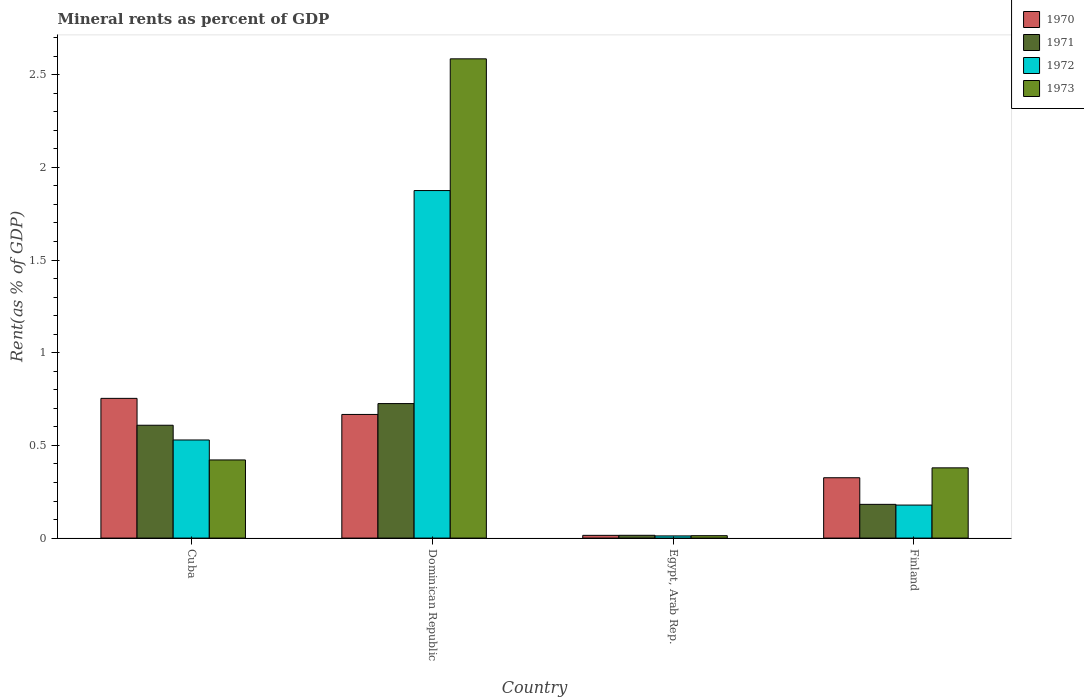How many different coloured bars are there?
Offer a terse response. 4. How many groups of bars are there?
Offer a terse response. 4. Are the number of bars per tick equal to the number of legend labels?
Your answer should be compact. Yes. How many bars are there on the 2nd tick from the left?
Provide a succinct answer. 4. What is the label of the 3rd group of bars from the left?
Provide a short and direct response. Egypt, Arab Rep. What is the mineral rent in 1970 in Finland?
Offer a terse response. 0.33. Across all countries, what is the maximum mineral rent in 1970?
Offer a very short reply. 0.75. Across all countries, what is the minimum mineral rent in 1971?
Your answer should be very brief. 0.02. In which country was the mineral rent in 1970 maximum?
Keep it short and to the point. Cuba. In which country was the mineral rent in 1970 minimum?
Offer a terse response. Egypt, Arab Rep. What is the total mineral rent in 1970 in the graph?
Provide a short and direct response. 1.76. What is the difference between the mineral rent in 1972 in Cuba and that in Finland?
Your response must be concise. 0.35. What is the difference between the mineral rent in 1971 in Dominican Republic and the mineral rent in 1973 in Finland?
Give a very brief answer. 0.35. What is the average mineral rent in 1972 per country?
Offer a very short reply. 0.65. What is the difference between the mineral rent of/in 1970 and mineral rent of/in 1971 in Cuba?
Give a very brief answer. 0.14. What is the ratio of the mineral rent in 1972 in Dominican Republic to that in Finland?
Keep it short and to the point. 10.53. Is the mineral rent in 1971 in Egypt, Arab Rep. less than that in Finland?
Your answer should be very brief. Yes. Is the difference between the mineral rent in 1970 in Dominican Republic and Egypt, Arab Rep. greater than the difference between the mineral rent in 1971 in Dominican Republic and Egypt, Arab Rep.?
Your answer should be compact. No. What is the difference between the highest and the second highest mineral rent in 1971?
Provide a short and direct response. 0.12. What is the difference between the highest and the lowest mineral rent in 1971?
Make the answer very short. 0.71. Is the sum of the mineral rent in 1972 in Cuba and Finland greater than the maximum mineral rent in 1971 across all countries?
Provide a succinct answer. No. What does the 1st bar from the left in Egypt, Arab Rep. represents?
Ensure brevity in your answer.  1970. Is it the case that in every country, the sum of the mineral rent in 1971 and mineral rent in 1972 is greater than the mineral rent in 1973?
Make the answer very short. No. How many countries are there in the graph?
Your response must be concise. 4. Are the values on the major ticks of Y-axis written in scientific E-notation?
Provide a succinct answer. No. Does the graph contain grids?
Offer a very short reply. No. Where does the legend appear in the graph?
Provide a succinct answer. Top right. How are the legend labels stacked?
Ensure brevity in your answer.  Vertical. What is the title of the graph?
Offer a very short reply. Mineral rents as percent of GDP. Does "2004" appear as one of the legend labels in the graph?
Your answer should be very brief. No. What is the label or title of the X-axis?
Offer a terse response. Country. What is the label or title of the Y-axis?
Provide a short and direct response. Rent(as % of GDP). What is the Rent(as % of GDP) of 1970 in Cuba?
Give a very brief answer. 0.75. What is the Rent(as % of GDP) in 1971 in Cuba?
Your response must be concise. 0.61. What is the Rent(as % of GDP) in 1972 in Cuba?
Ensure brevity in your answer.  0.53. What is the Rent(as % of GDP) of 1973 in Cuba?
Ensure brevity in your answer.  0.42. What is the Rent(as % of GDP) of 1970 in Dominican Republic?
Make the answer very short. 0.67. What is the Rent(as % of GDP) of 1971 in Dominican Republic?
Offer a very short reply. 0.73. What is the Rent(as % of GDP) in 1972 in Dominican Republic?
Your response must be concise. 1.87. What is the Rent(as % of GDP) of 1973 in Dominican Republic?
Your answer should be compact. 2.59. What is the Rent(as % of GDP) in 1970 in Egypt, Arab Rep.?
Offer a terse response. 0.01. What is the Rent(as % of GDP) of 1971 in Egypt, Arab Rep.?
Give a very brief answer. 0.02. What is the Rent(as % of GDP) of 1972 in Egypt, Arab Rep.?
Provide a succinct answer. 0.01. What is the Rent(as % of GDP) of 1973 in Egypt, Arab Rep.?
Your answer should be compact. 0.01. What is the Rent(as % of GDP) in 1970 in Finland?
Provide a short and direct response. 0.33. What is the Rent(as % of GDP) in 1971 in Finland?
Your answer should be very brief. 0.18. What is the Rent(as % of GDP) of 1972 in Finland?
Offer a terse response. 0.18. What is the Rent(as % of GDP) in 1973 in Finland?
Give a very brief answer. 0.38. Across all countries, what is the maximum Rent(as % of GDP) of 1970?
Keep it short and to the point. 0.75. Across all countries, what is the maximum Rent(as % of GDP) of 1971?
Keep it short and to the point. 0.73. Across all countries, what is the maximum Rent(as % of GDP) in 1972?
Provide a succinct answer. 1.87. Across all countries, what is the maximum Rent(as % of GDP) in 1973?
Offer a very short reply. 2.59. Across all countries, what is the minimum Rent(as % of GDP) in 1970?
Your answer should be compact. 0.01. Across all countries, what is the minimum Rent(as % of GDP) in 1971?
Ensure brevity in your answer.  0.02. Across all countries, what is the minimum Rent(as % of GDP) in 1972?
Make the answer very short. 0.01. Across all countries, what is the minimum Rent(as % of GDP) in 1973?
Offer a terse response. 0.01. What is the total Rent(as % of GDP) of 1970 in the graph?
Your response must be concise. 1.76. What is the total Rent(as % of GDP) in 1971 in the graph?
Give a very brief answer. 1.53. What is the total Rent(as % of GDP) in 1972 in the graph?
Ensure brevity in your answer.  2.59. What is the total Rent(as % of GDP) in 1973 in the graph?
Provide a short and direct response. 3.4. What is the difference between the Rent(as % of GDP) in 1970 in Cuba and that in Dominican Republic?
Offer a terse response. 0.09. What is the difference between the Rent(as % of GDP) of 1971 in Cuba and that in Dominican Republic?
Your response must be concise. -0.12. What is the difference between the Rent(as % of GDP) in 1972 in Cuba and that in Dominican Republic?
Make the answer very short. -1.35. What is the difference between the Rent(as % of GDP) in 1973 in Cuba and that in Dominican Republic?
Provide a succinct answer. -2.16. What is the difference between the Rent(as % of GDP) of 1970 in Cuba and that in Egypt, Arab Rep.?
Ensure brevity in your answer.  0.74. What is the difference between the Rent(as % of GDP) in 1971 in Cuba and that in Egypt, Arab Rep.?
Offer a terse response. 0.59. What is the difference between the Rent(as % of GDP) of 1972 in Cuba and that in Egypt, Arab Rep.?
Keep it short and to the point. 0.52. What is the difference between the Rent(as % of GDP) of 1973 in Cuba and that in Egypt, Arab Rep.?
Offer a very short reply. 0.41. What is the difference between the Rent(as % of GDP) of 1970 in Cuba and that in Finland?
Make the answer very short. 0.43. What is the difference between the Rent(as % of GDP) in 1971 in Cuba and that in Finland?
Your answer should be compact. 0.43. What is the difference between the Rent(as % of GDP) of 1972 in Cuba and that in Finland?
Provide a succinct answer. 0.35. What is the difference between the Rent(as % of GDP) of 1973 in Cuba and that in Finland?
Ensure brevity in your answer.  0.04. What is the difference between the Rent(as % of GDP) of 1970 in Dominican Republic and that in Egypt, Arab Rep.?
Offer a very short reply. 0.65. What is the difference between the Rent(as % of GDP) in 1971 in Dominican Republic and that in Egypt, Arab Rep.?
Your answer should be compact. 0.71. What is the difference between the Rent(as % of GDP) of 1972 in Dominican Republic and that in Egypt, Arab Rep.?
Give a very brief answer. 1.86. What is the difference between the Rent(as % of GDP) of 1973 in Dominican Republic and that in Egypt, Arab Rep.?
Give a very brief answer. 2.57. What is the difference between the Rent(as % of GDP) in 1970 in Dominican Republic and that in Finland?
Your answer should be compact. 0.34. What is the difference between the Rent(as % of GDP) of 1971 in Dominican Republic and that in Finland?
Keep it short and to the point. 0.54. What is the difference between the Rent(as % of GDP) of 1972 in Dominican Republic and that in Finland?
Provide a succinct answer. 1.7. What is the difference between the Rent(as % of GDP) of 1973 in Dominican Republic and that in Finland?
Give a very brief answer. 2.21. What is the difference between the Rent(as % of GDP) of 1970 in Egypt, Arab Rep. and that in Finland?
Keep it short and to the point. -0.31. What is the difference between the Rent(as % of GDP) of 1971 in Egypt, Arab Rep. and that in Finland?
Offer a terse response. -0.17. What is the difference between the Rent(as % of GDP) in 1972 in Egypt, Arab Rep. and that in Finland?
Offer a very short reply. -0.17. What is the difference between the Rent(as % of GDP) in 1973 in Egypt, Arab Rep. and that in Finland?
Your answer should be compact. -0.37. What is the difference between the Rent(as % of GDP) of 1970 in Cuba and the Rent(as % of GDP) of 1971 in Dominican Republic?
Keep it short and to the point. 0.03. What is the difference between the Rent(as % of GDP) of 1970 in Cuba and the Rent(as % of GDP) of 1972 in Dominican Republic?
Your answer should be compact. -1.12. What is the difference between the Rent(as % of GDP) in 1970 in Cuba and the Rent(as % of GDP) in 1973 in Dominican Republic?
Make the answer very short. -1.83. What is the difference between the Rent(as % of GDP) in 1971 in Cuba and the Rent(as % of GDP) in 1972 in Dominican Republic?
Offer a very short reply. -1.27. What is the difference between the Rent(as % of GDP) in 1971 in Cuba and the Rent(as % of GDP) in 1973 in Dominican Republic?
Offer a terse response. -1.98. What is the difference between the Rent(as % of GDP) of 1972 in Cuba and the Rent(as % of GDP) of 1973 in Dominican Republic?
Your answer should be very brief. -2.06. What is the difference between the Rent(as % of GDP) in 1970 in Cuba and the Rent(as % of GDP) in 1971 in Egypt, Arab Rep.?
Give a very brief answer. 0.74. What is the difference between the Rent(as % of GDP) in 1970 in Cuba and the Rent(as % of GDP) in 1972 in Egypt, Arab Rep.?
Ensure brevity in your answer.  0.74. What is the difference between the Rent(as % of GDP) in 1970 in Cuba and the Rent(as % of GDP) in 1973 in Egypt, Arab Rep.?
Your answer should be compact. 0.74. What is the difference between the Rent(as % of GDP) of 1971 in Cuba and the Rent(as % of GDP) of 1972 in Egypt, Arab Rep.?
Offer a terse response. 0.6. What is the difference between the Rent(as % of GDP) of 1971 in Cuba and the Rent(as % of GDP) of 1973 in Egypt, Arab Rep.?
Offer a terse response. 0.6. What is the difference between the Rent(as % of GDP) of 1972 in Cuba and the Rent(as % of GDP) of 1973 in Egypt, Arab Rep.?
Keep it short and to the point. 0.52. What is the difference between the Rent(as % of GDP) of 1970 in Cuba and the Rent(as % of GDP) of 1971 in Finland?
Provide a short and direct response. 0.57. What is the difference between the Rent(as % of GDP) in 1970 in Cuba and the Rent(as % of GDP) in 1972 in Finland?
Ensure brevity in your answer.  0.58. What is the difference between the Rent(as % of GDP) of 1970 in Cuba and the Rent(as % of GDP) of 1973 in Finland?
Ensure brevity in your answer.  0.37. What is the difference between the Rent(as % of GDP) of 1971 in Cuba and the Rent(as % of GDP) of 1972 in Finland?
Give a very brief answer. 0.43. What is the difference between the Rent(as % of GDP) in 1971 in Cuba and the Rent(as % of GDP) in 1973 in Finland?
Keep it short and to the point. 0.23. What is the difference between the Rent(as % of GDP) of 1972 in Cuba and the Rent(as % of GDP) of 1973 in Finland?
Keep it short and to the point. 0.15. What is the difference between the Rent(as % of GDP) in 1970 in Dominican Republic and the Rent(as % of GDP) in 1971 in Egypt, Arab Rep.?
Your answer should be very brief. 0.65. What is the difference between the Rent(as % of GDP) of 1970 in Dominican Republic and the Rent(as % of GDP) of 1972 in Egypt, Arab Rep.?
Ensure brevity in your answer.  0.66. What is the difference between the Rent(as % of GDP) in 1970 in Dominican Republic and the Rent(as % of GDP) in 1973 in Egypt, Arab Rep.?
Make the answer very short. 0.65. What is the difference between the Rent(as % of GDP) of 1971 in Dominican Republic and the Rent(as % of GDP) of 1972 in Egypt, Arab Rep.?
Make the answer very short. 0.71. What is the difference between the Rent(as % of GDP) in 1971 in Dominican Republic and the Rent(as % of GDP) in 1973 in Egypt, Arab Rep.?
Your response must be concise. 0.71. What is the difference between the Rent(as % of GDP) of 1972 in Dominican Republic and the Rent(as % of GDP) of 1973 in Egypt, Arab Rep.?
Ensure brevity in your answer.  1.86. What is the difference between the Rent(as % of GDP) of 1970 in Dominican Republic and the Rent(as % of GDP) of 1971 in Finland?
Keep it short and to the point. 0.48. What is the difference between the Rent(as % of GDP) of 1970 in Dominican Republic and the Rent(as % of GDP) of 1972 in Finland?
Your answer should be compact. 0.49. What is the difference between the Rent(as % of GDP) in 1970 in Dominican Republic and the Rent(as % of GDP) in 1973 in Finland?
Your answer should be very brief. 0.29. What is the difference between the Rent(as % of GDP) in 1971 in Dominican Republic and the Rent(as % of GDP) in 1972 in Finland?
Make the answer very short. 0.55. What is the difference between the Rent(as % of GDP) of 1971 in Dominican Republic and the Rent(as % of GDP) of 1973 in Finland?
Your answer should be compact. 0.35. What is the difference between the Rent(as % of GDP) of 1972 in Dominican Republic and the Rent(as % of GDP) of 1973 in Finland?
Provide a short and direct response. 1.5. What is the difference between the Rent(as % of GDP) in 1970 in Egypt, Arab Rep. and the Rent(as % of GDP) in 1971 in Finland?
Offer a very short reply. -0.17. What is the difference between the Rent(as % of GDP) in 1970 in Egypt, Arab Rep. and the Rent(as % of GDP) in 1972 in Finland?
Your answer should be compact. -0.16. What is the difference between the Rent(as % of GDP) of 1970 in Egypt, Arab Rep. and the Rent(as % of GDP) of 1973 in Finland?
Make the answer very short. -0.36. What is the difference between the Rent(as % of GDP) in 1971 in Egypt, Arab Rep. and the Rent(as % of GDP) in 1972 in Finland?
Offer a terse response. -0.16. What is the difference between the Rent(as % of GDP) in 1971 in Egypt, Arab Rep. and the Rent(as % of GDP) in 1973 in Finland?
Your answer should be very brief. -0.36. What is the difference between the Rent(as % of GDP) of 1972 in Egypt, Arab Rep. and the Rent(as % of GDP) of 1973 in Finland?
Make the answer very short. -0.37. What is the average Rent(as % of GDP) in 1970 per country?
Your answer should be very brief. 0.44. What is the average Rent(as % of GDP) of 1971 per country?
Your answer should be very brief. 0.38. What is the average Rent(as % of GDP) in 1972 per country?
Your response must be concise. 0.65. What is the average Rent(as % of GDP) of 1973 per country?
Provide a short and direct response. 0.85. What is the difference between the Rent(as % of GDP) in 1970 and Rent(as % of GDP) in 1971 in Cuba?
Make the answer very short. 0.14. What is the difference between the Rent(as % of GDP) in 1970 and Rent(as % of GDP) in 1972 in Cuba?
Make the answer very short. 0.22. What is the difference between the Rent(as % of GDP) of 1970 and Rent(as % of GDP) of 1973 in Cuba?
Provide a short and direct response. 0.33. What is the difference between the Rent(as % of GDP) in 1971 and Rent(as % of GDP) in 1972 in Cuba?
Ensure brevity in your answer.  0.08. What is the difference between the Rent(as % of GDP) of 1971 and Rent(as % of GDP) of 1973 in Cuba?
Offer a terse response. 0.19. What is the difference between the Rent(as % of GDP) of 1972 and Rent(as % of GDP) of 1973 in Cuba?
Keep it short and to the point. 0.11. What is the difference between the Rent(as % of GDP) in 1970 and Rent(as % of GDP) in 1971 in Dominican Republic?
Ensure brevity in your answer.  -0.06. What is the difference between the Rent(as % of GDP) of 1970 and Rent(as % of GDP) of 1972 in Dominican Republic?
Provide a succinct answer. -1.21. What is the difference between the Rent(as % of GDP) in 1970 and Rent(as % of GDP) in 1973 in Dominican Republic?
Offer a very short reply. -1.92. What is the difference between the Rent(as % of GDP) of 1971 and Rent(as % of GDP) of 1972 in Dominican Republic?
Make the answer very short. -1.15. What is the difference between the Rent(as % of GDP) of 1971 and Rent(as % of GDP) of 1973 in Dominican Republic?
Provide a short and direct response. -1.86. What is the difference between the Rent(as % of GDP) in 1972 and Rent(as % of GDP) in 1973 in Dominican Republic?
Provide a short and direct response. -0.71. What is the difference between the Rent(as % of GDP) in 1970 and Rent(as % of GDP) in 1971 in Egypt, Arab Rep.?
Keep it short and to the point. -0. What is the difference between the Rent(as % of GDP) in 1970 and Rent(as % of GDP) in 1972 in Egypt, Arab Rep.?
Provide a succinct answer. 0. What is the difference between the Rent(as % of GDP) of 1970 and Rent(as % of GDP) of 1973 in Egypt, Arab Rep.?
Keep it short and to the point. 0. What is the difference between the Rent(as % of GDP) in 1971 and Rent(as % of GDP) in 1972 in Egypt, Arab Rep.?
Offer a very short reply. 0. What is the difference between the Rent(as % of GDP) of 1971 and Rent(as % of GDP) of 1973 in Egypt, Arab Rep.?
Your answer should be very brief. 0. What is the difference between the Rent(as % of GDP) in 1972 and Rent(as % of GDP) in 1973 in Egypt, Arab Rep.?
Give a very brief answer. -0. What is the difference between the Rent(as % of GDP) of 1970 and Rent(as % of GDP) of 1971 in Finland?
Give a very brief answer. 0.14. What is the difference between the Rent(as % of GDP) of 1970 and Rent(as % of GDP) of 1972 in Finland?
Keep it short and to the point. 0.15. What is the difference between the Rent(as % of GDP) in 1970 and Rent(as % of GDP) in 1973 in Finland?
Your answer should be compact. -0.05. What is the difference between the Rent(as % of GDP) of 1971 and Rent(as % of GDP) of 1972 in Finland?
Make the answer very short. 0. What is the difference between the Rent(as % of GDP) in 1971 and Rent(as % of GDP) in 1973 in Finland?
Your answer should be compact. -0.2. What is the difference between the Rent(as % of GDP) of 1972 and Rent(as % of GDP) of 1973 in Finland?
Provide a short and direct response. -0.2. What is the ratio of the Rent(as % of GDP) of 1970 in Cuba to that in Dominican Republic?
Make the answer very short. 1.13. What is the ratio of the Rent(as % of GDP) in 1971 in Cuba to that in Dominican Republic?
Provide a succinct answer. 0.84. What is the ratio of the Rent(as % of GDP) in 1972 in Cuba to that in Dominican Republic?
Offer a very short reply. 0.28. What is the ratio of the Rent(as % of GDP) in 1973 in Cuba to that in Dominican Republic?
Your answer should be compact. 0.16. What is the ratio of the Rent(as % of GDP) of 1970 in Cuba to that in Egypt, Arab Rep.?
Offer a terse response. 51. What is the ratio of the Rent(as % of GDP) of 1971 in Cuba to that in Egypt, Arab Rep.?
Keep it short and to the point. 40.5. What is the ratio of the Rent(as % of GDP) of 1972 in Cuba to that in Egypt, Arab Rep.?
Your answer should be very brief. 45.11. What is the ratio of the Rent(as % of GDP) in 1973 in Cuba to that in Egypt, Arab Rep.?
Your response must be concise. 32.3. What is the ratio of the Rent(as % of GDP) of 1970 in Cuba to that in Finland?
Offer a terse response. 2.32. What is the ratio of the Rent(as % of GDP) of 1971 in Cuba to that in Finland?
Offer a very short reply. 3.34. What is the ratio of the Rent(as % of GDP) in 1972 in Cuba to that in Finland?
Your response must be concise. 2.97. What is the ratio of the Rent(as % of GDP) of 1973 in Cuba to that in Finland?
Offer a very short reply. 1.11. What is the ratio of the Rent(as % of GDP) in 1970 in Dominican Republic to that in Egypt, Arab Rep.?
Your answer should be very brief. 45.13. What is the ratio of the Rent(as % of GDP) of 1971 in Dominican Republic to that in Egypt, Arab Rep.?
Make the answer very short. 48.27. What is the ratio of the Rent(as % of GDP) of 1972 in Dominican Republic to that in Egypt, Arab Rep.?
Your answer should be very brief. 159.8. What is the ratio of the Rent(as % of GDP) in 1973 in Dominican Republic to that in Egypt, Arab Rep.?
Your answer should be very brief. 198.1. What is the ratio of the Rent(as % of GDP) in 1970 in Dominican Republic to that in Finland?
Your answer should be compact. 2.05. What is the ratio of the Rent(as % of GDP) in 1971 in Dominican Republic to that in Finland?
Ensure brevity in your answer.  3.99. What is the ratio of the Rent(as % of GDP) of 1972 in Dominican Republic to that in Finland?
Provide a succinct answer. 10.53. What is the ratio of the Rent(as % of GDP) in 1973 in Dominican Republic to that in Finland?
Offer a very short reply. 6.82. What is the ratio of the Rent(as % of GDP) in 1970 in Egypt, Arab Rep. to that in Finland?
Make the answer very short. 0.05. What is the ratio of the Rent(as % of GDP) in 1971 in Egypt, Arab Rep. to that in Finland?
Make the answer very short. 0.08. What is the ratio of the Rent(as % of GDP) in 1972 in Egypt, Arab Rep. to that in Finland?
Your response must be concise. 0.07. What is the ratio of the Rent(as % of GDP) in 1973 in Egypt, Arab Rep. to that in Finland?
Make the answer very short. 0.03. What is the difference between the highest and the second highest Rent(as % of GDP) in 1970?
Ensure brevity in your answer.  0.09. What is the difference between the highest and the second highest Rent(as % of GDP) of 1971?
Provide a succinct answer. 0.12. What is the difference between the highest and the second highest Rent(as % of GDP) of 1972?
Your answer should be very brief. 1.35. What is the difference between the highest and the second highest Rent(as % of GDP) of 1973?
Your response must be concise. 2.16. What is the difference between the highest and the lowest Rent(as % of GDP) in 1970?
Offer a terse response. 0.74. What is the difference between the highest and the lowest Rent(as % of GDP) in 1971?
Provide a succinct answer. 0.71. What is the difference between the highest and the lowest Rent(as % of GDP) in 1972?
Provide a succinct answer. 1.86. What is the difference between the highest and the lowest Rent(as % of GDP) in 1973?
Offer a terse response. 2.57. 